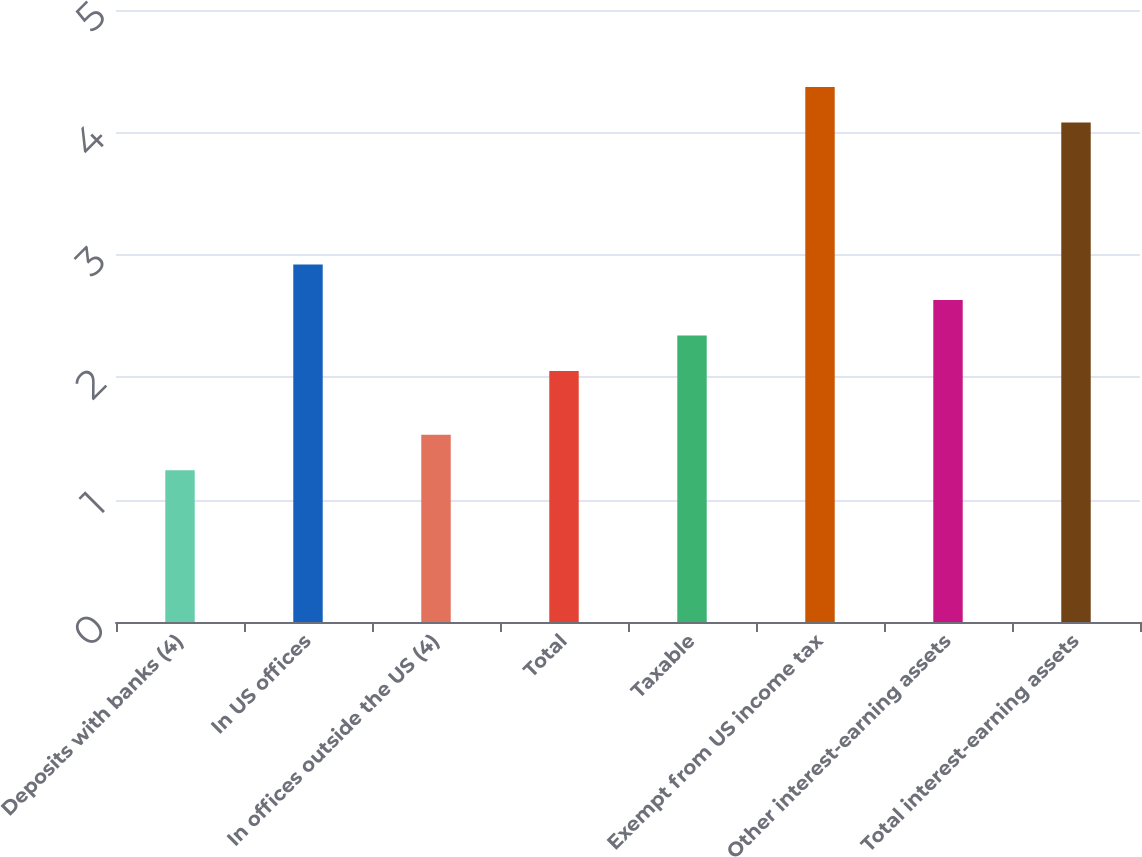Convert chart. <chart><loc_0><loc_0><loc_500><loc_500><bar_chart><fcel>Deposits with banks (4)<fcel>In US offices<fcel>In offices outside the US (4)<fcel>Total<fcel>Taxable<fcel>Exempt from US income tax<fcel>Other interest-earning assets<fcel>Total interest-earning assets<nl><fcel>1.24<fcel>2.92<fcel>1.53<fcel>2.05<fcel>2.34<fcel>4.37<fcel>2.63<fcel>4.08<nl></chart> 